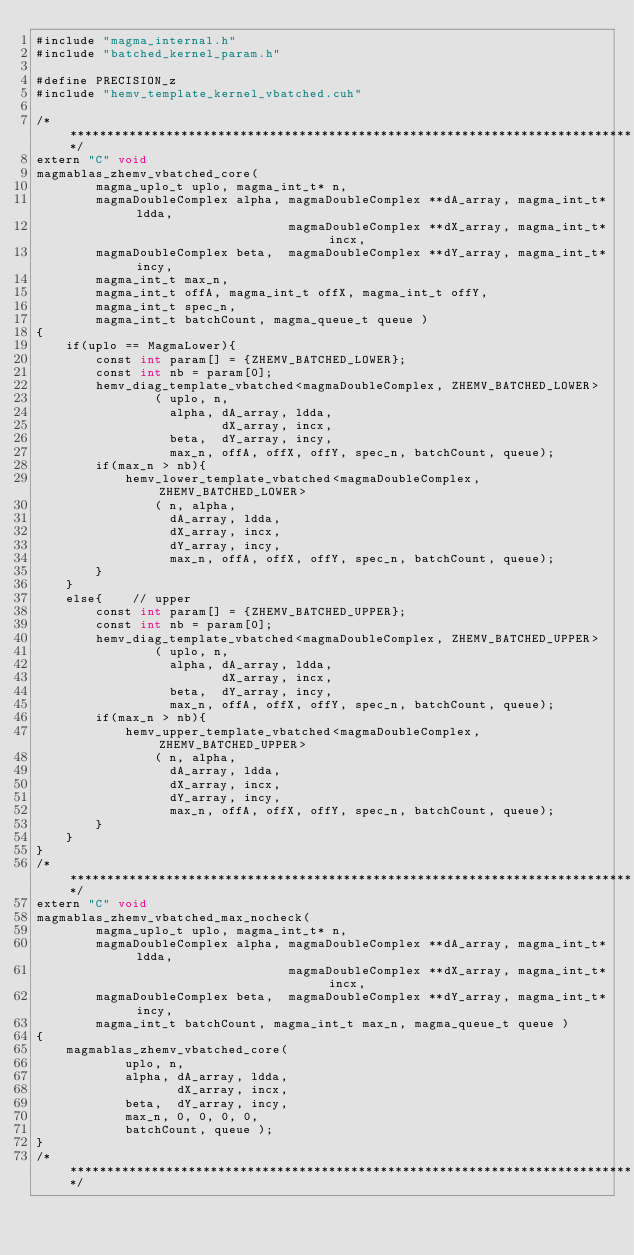Convert code to text. <code><loc_0><loc_0><loc_500><loc_500><_Cuda_>#include "magma_internal.h"
#include "batched_kernel_param.h"

#define PRECISION_z
#include "hemv_template_kernel_vbatched.cuh"

/******************************************************************************/
extern "C" void 
magmablas_zhemv_vbatched_core(
        magma_uplo_t uplo, magma_int_t* n, 
        magmaDoubleComplex alpha, magmaDoubleComplex **dA_array, magma_int_t* ldda,
                                  magmaDoubleComplex **dX_array, magma_int_t* incx,
        magmaDoubleComplex beta,  magmaDoubleComplex **dY_array, magma_int_t* incy,
        magma_int_t max_n, 
        magma_int_t offA, magma_int_t offX, magma_int_t offY, 
        magma_int_t spec_n, 
        magma_int_t batchCount, magma_queue_t queue )
{
    if(uplo == MagmaLower){
        const int param[] = {ZHEMV_BATCHED_LOWER};
        const int nb = param[0];
        hemv_diag_template_vbatched<magmaDoubleComplex, ZHEMV_BATCHED_LOWER>
                ( uplo, n, 
                  alpha, dA_array, ldda, 
                         dX_array, incx, 
                  beta,  dY_array, incy, 
                  max_n, offA, offX, offY, spec_n, batchCount, queue);
        if(max_n > nb){
            hemv_lower_template_vbatched<magmaDoubleComplex, ZHEMV_BATCHED_LOWER>
                ( n, alpha, 
                  dA_array, ldda, 
                  dX_array, incx, 
                  dY_array, incy, 
                  max_n, offA, offX, offY, spec_n, batchCount, queue);
        }
    }
    else{    // upper
        const int param[] = {ZHEMV_BATCHED_UPPER};
        const int nb = param[0];
        hemv_diag_template_vbatched<magmaDoubleComplex, ZHEMV_BATCHED_UPPER>
                ( uplo, n, 
                  alpha, dA_array, ldda, 
                         dX_array, incx, 
                  beta,  dY_array, incy, 
                  max_n, offA, offX, offY, spec_n, batchCount, queue);
        if(max_n > nb){
            hemv_upper_template_vbatched<magmaDoubleComplex, ZHEMV_BATCHED_UPPER>
                ( n, alpha, 
                  dA_array, ldda, 
                  dX_array, incx, 
                  dY_array, incy, 
                  max_n, offA, offX, offY, spec_n, batchCount, queue);
        }
    }
}
/******************************************************************************/
extern "C" void 
magmablas_zhemv_vbatched_max_nocheck(
        magma_uplo_t uplo, magma_int_t* n, 
        magmaDoubleComplex alpha, magmaDoubleComplex **dA_array, magma_int_t* ldda,
                                  magmaDoubleComplex **dX_array, magma_int_t* incx,
        magmaDoubleComplex beta,  magmaDoubleComplex **dY_array, magma_int_t* incy, 
        magma_int_t batchCount, magma_int_t max_n, magma_queue_t queue )
{
    magmablas_zhemv_vbatched_core( 
            uplo, n, 
            alpha, dA_array, ldda, 
                   dX_array, incx,
            beta,  dY_array, incy,  
            max_n, 0, 0, 0, 0, 
            batchCount, queue );
}
/******************************************************************************/
</code> 